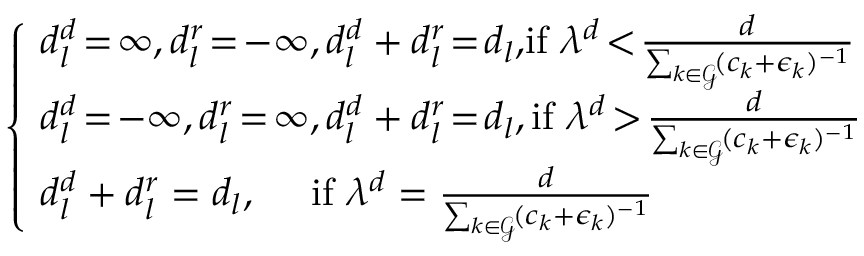<formula> <loc_0><loc_0><loc_500><loc_500>\begin{array} { r } { \, \left \{ \begin{array} { l } { \, d _ { l } ^ { d } \, = \, \infty , d _ { l } ^ { r } \, = \, - \infty , d _ { l } ^ { d } + d _ { l } ^ { r } \, = \, d _ { l } , \, i f \lambda ^ { d } \, < \, \frac { d } { \sum _ { k \in \mathcal { G } } \, ( c _ { k } + \epsilon _ { k } ) ^ { - 1 } } } \\ { \, d _ { l } ^ { d } \, = \, - \infty , d _ { l } ^ { r } \, = \, \infty , d _ { l } ^ { d } + d _ { l } ^ { r } \, = \, d _ { l } , i f \lambda ^ { d } \, > \, \frac { d } { \sum _ { k \in \mathcal { G } } \, ( c _ { k } + \epsilon _ { k } ) ^ { - 1 } } } \\ { \, d _ { l } ^ { d } + d _ { l } ^ { r } = d _ { l } , \quad i f \lambda ^ { d } = \frac { d } { \sum _ { k \in \mathcal { G } } \, ( c _ { k } + \epsilon _ { k } ) ^ { - 1 } } } \end{array} } \end{array}</formula> 